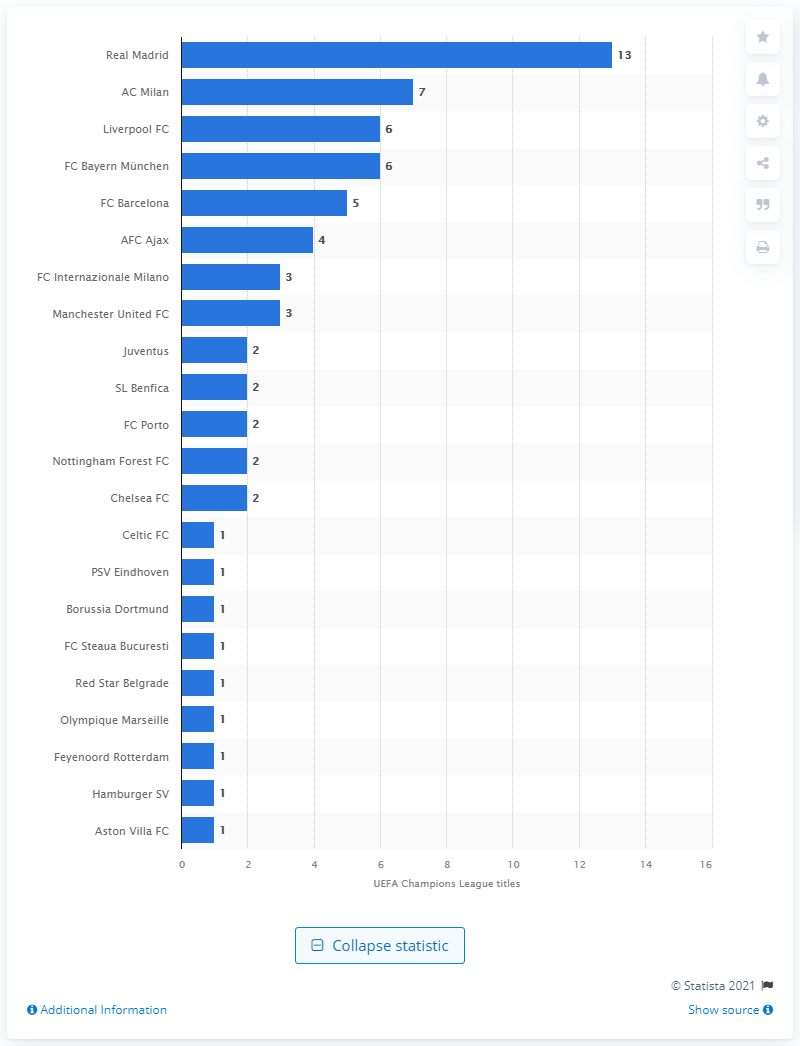Indicate a few pertinent items in this graphic. Real Madrid has won the European Cup a total of 13 times. Real Madrid is the most successful team in the history of the European Cup. 